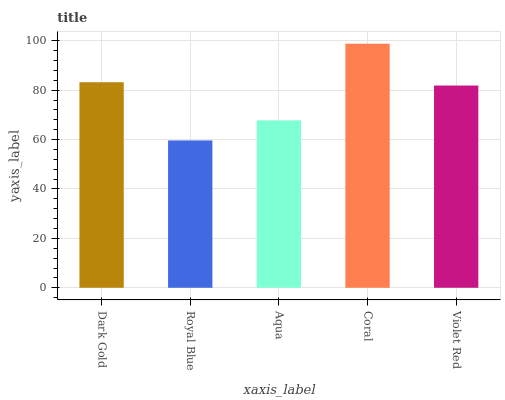Is Royal Blue the minimum?
Answer yes or no. Yes. Is Coral the maximum?
Answer yes or no. Yes. Is Aqua the minimum?
Answer yes or no. No. Is Aqua the maximum?
Answer yes or no. No. Is Aqua greater than Royal Blue?
Answer yes or no. Yes. Is Royal Blue less than Aqua?
Answer yes or no. Yes. Is Royal Blue greater than Aqua?
Answer yes or no. No. Is Aqua less than Royal Blue?
Answer yes or no. No. Is Violet Red the high median?
Answer yes or no. Yes. Is Violet Red the low median?
Answer yes or no. Yes. Is Coral the high median?
Answer yes or no. No. Is Royal Blue the low median?
Answer yes or no. No. 